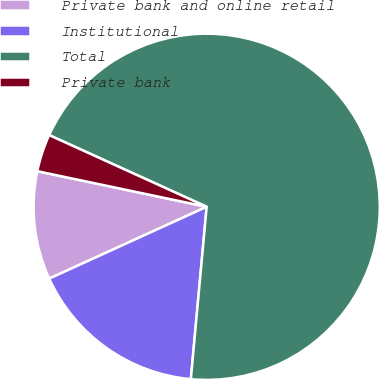Convert chart. <chart><loc_0><loc_0><loc_500><loc_500><pie_chart><fcel>Private bank and online retail<fcel>Institutional<fcel>Total<fcel>Private bank<nl><fcel>10.11%<fcel>16.73%<fcel>69.66%<fcel>3.5%<nl></chart> 